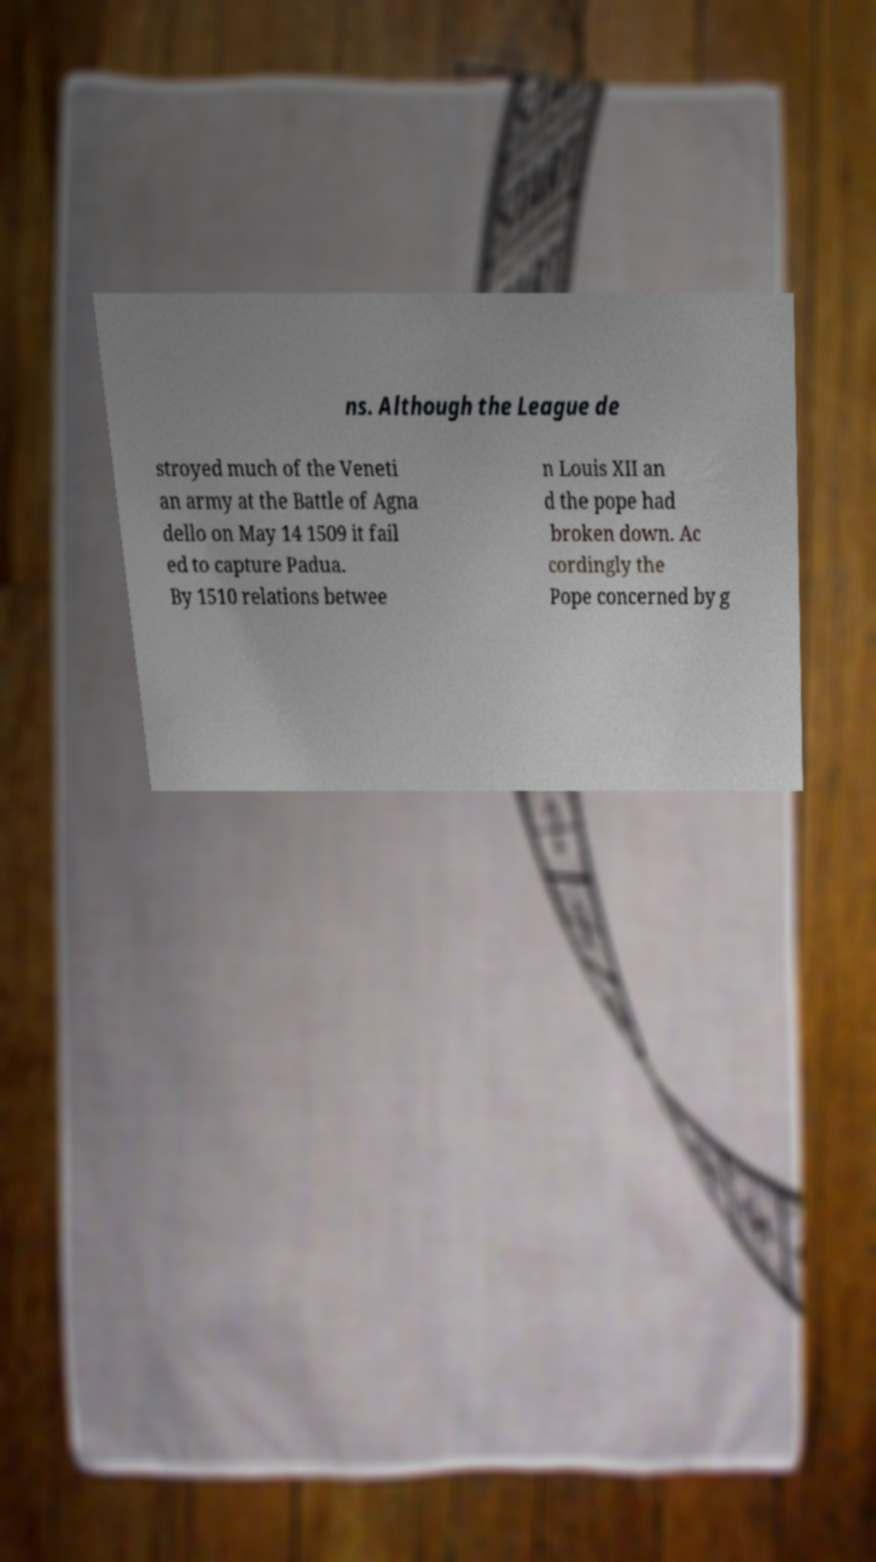For documentation purposes, I need the text within this image transcribed. Could you provide that? ns. Although the League de stroyed much of the Veneti an army at the Battle of Agna dello on May 14 1509 it fail ed to capture Padua. By 1510 relations betwee n Louis XII an d the pope had broken down. Ac cordingly the Pope concerned by g 